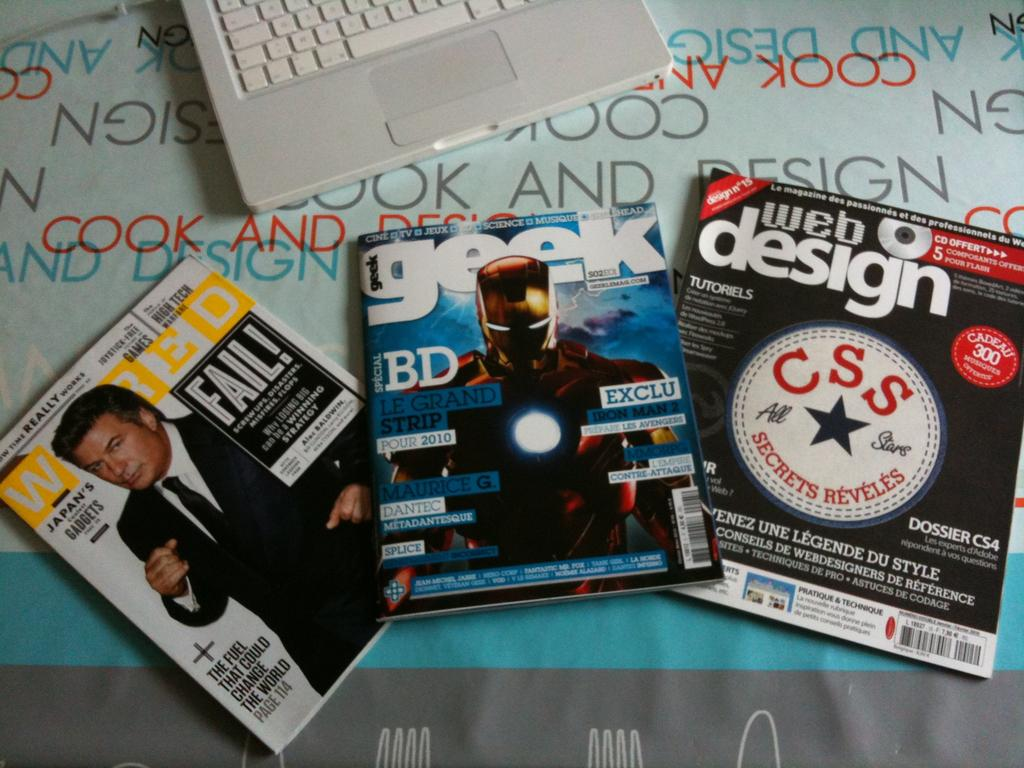What type of objects can be seen in the image? There are books and a laptop in the image. Where are the books and laptop located? The books and laptop are on an object. What type of copper or lead material is used to create the books in the image? The books in the image are not made of copper or lead; they are likely made of paper or other materials commonly used for books. 